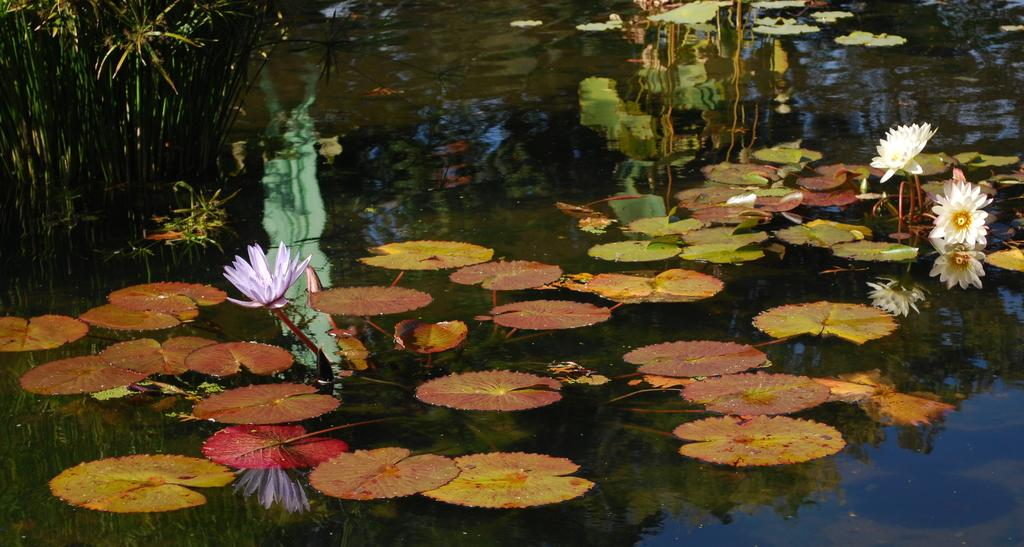What type of living organisms can be seen in the image? Flowers, leaves, and plants are visible in the image. What is the primary element in which the flowers, leaves, and plants are situated? The flowers, leaves, and plants are in water. What can be inferred about the environment in the image? The presence of water and plants suggests a natural or aquatic setting. What type of flock can be seen flying in the image? There is no flock of birds or any other flying animals present in the image. 